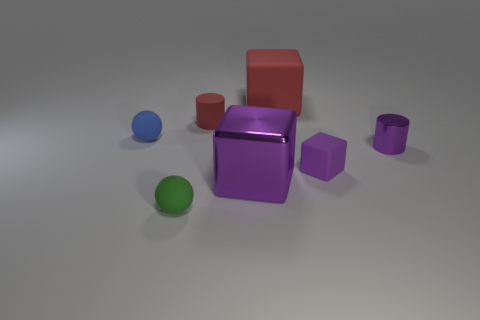Add 3 cyan shiny cubes. How many objects exist? 10 Subtract all balls. How many objects are left? 5 Add 3 small spheres. How many small spheres are left? 5 Add 1 small red things. How many small red things exist? 2 Subtract 0 brown cubes. How many objects are left? 7 Subtract all small metallic cylinders. Subtract all large metallic blocks. How many objects are left? 5 